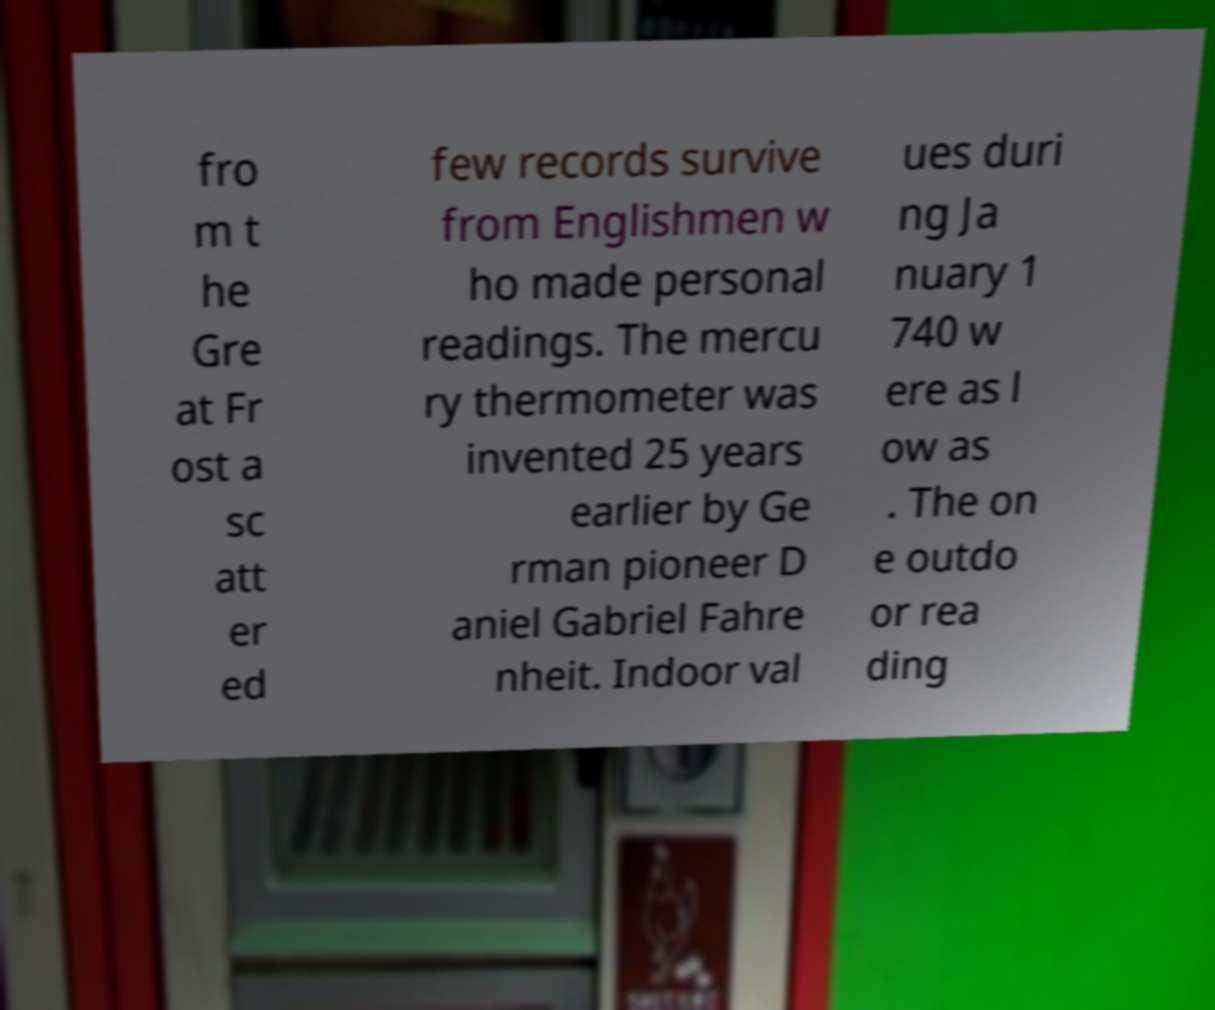Can you accurately transcribe the text from the provided image for me? fro m t he Gre at Fr ost a sc att er ed few records survive from Englishmen w ho made personal readings. The mercu ry thermometer was invented 25 years earlier by Ge rman pioneer D aniel Gabriel Fahre nheit. Indoor val ues duri ng Ja nuary 1 740 w ere as l ow as . The on e outdo or rea ding 